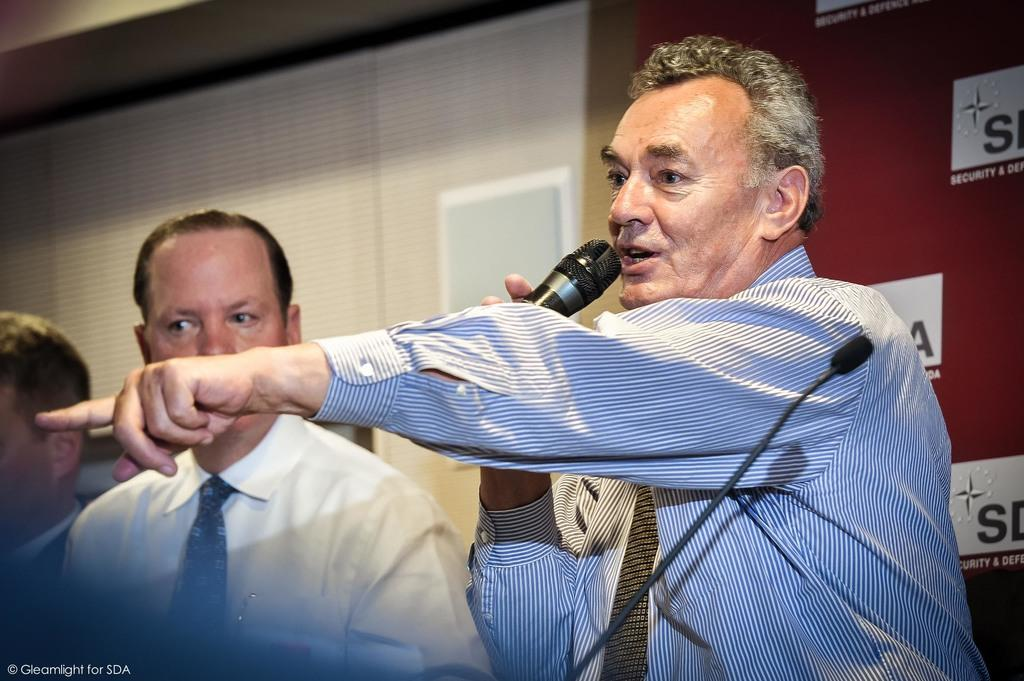How many people are present in the image? There are three persons in the image. What is one person doing with his hand? One person is holding a mic in his hand. What can be found in the bottom left corner of the image? There is text in the bottom left corner of the image. What is visible in the background of the image? There is a wall in the background, and a curtain is associated with the wall. What type of hook is being used to hold the haircut in the image? There is no hook or haircut present in the image. What kind of knife can be seen in the hands of one of the persons in the image? There is no knife visible in the hands of any person in the image. 